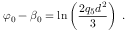<formula> <loc_0><loc_0><loc_500><loc_500>\varphi _ { 0 } - \beta _ { 0 } = \ln \left ( \frac { 2 q _ { 5 } d ^ { 2 } } { 3 } \right ) \, .</formula> 